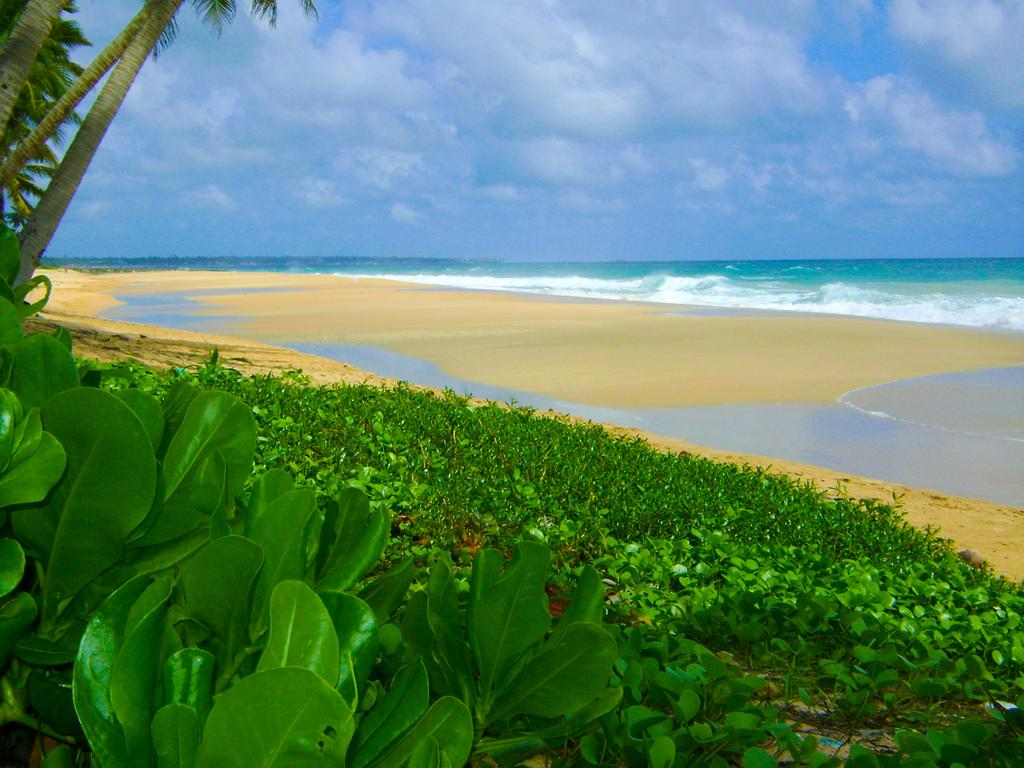What is located in the center of the image? There are plants, grass, and trees in the center of the image. What can be seen in the background of the image? The sky, clouds, and water are visible in the background of the image. How many types of vegetation are present in the center of the image? There are three types of vegetation: plants, grass, and trees. Can you tell me what type of pet is playing with the kitty in the image? There is no pet or kitty present in the image; it features plants, grass, trees, and a background with sky, clouds, and water. 